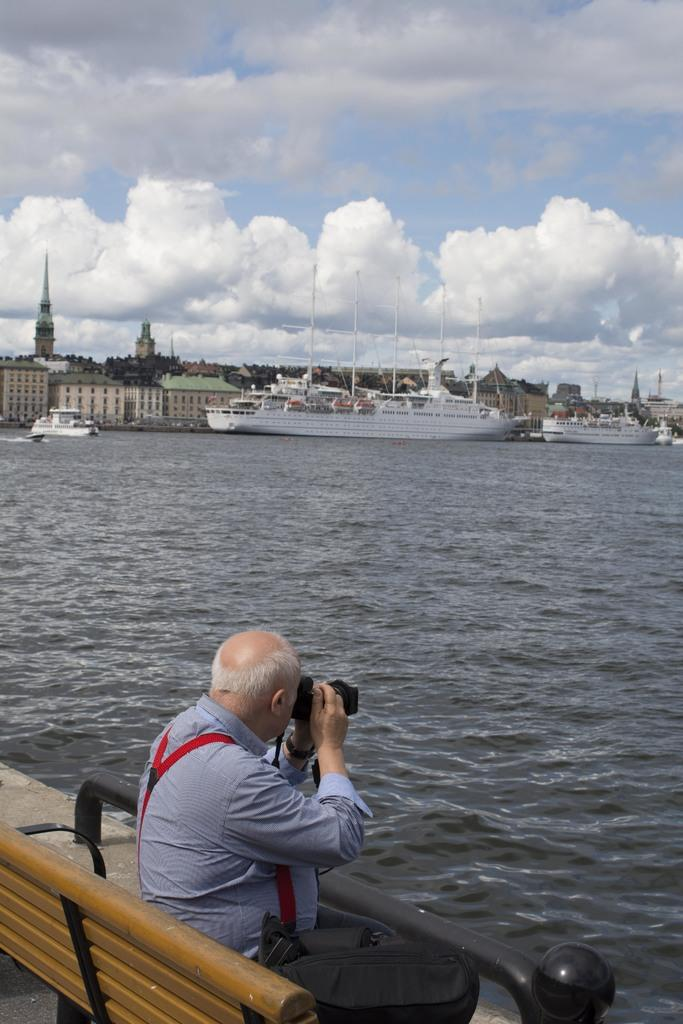What is the man in the image doing? The man is sitting on a bench in the image. What is the man holding in the image? The man is holding a camera in the image. What can be seen in the background of the image? There is water visible in the image, and ships are in the water. What is the condition of the sky in the image? The sky is cloudy in the image. How many clocks can be seen on the man's knee in the image? There are no clocks visible on the man's knee in the image. Who created the ships in the water? The provided facts do not mention the creator of the ships, so it cannot be determined from the image. 